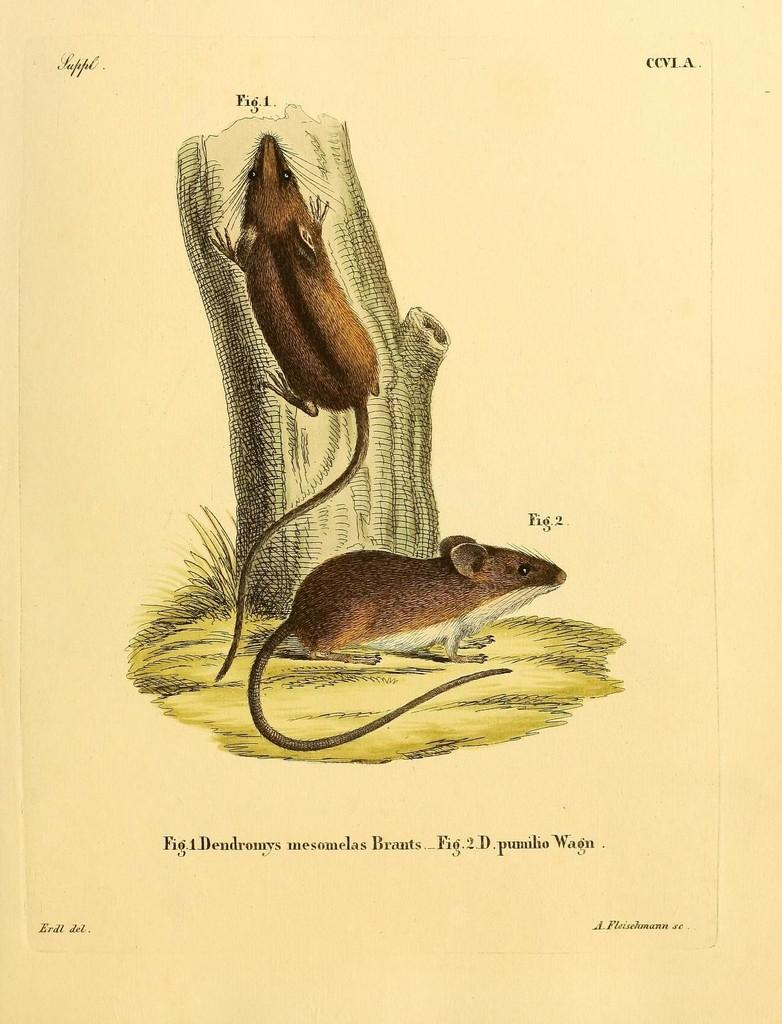What is present on the paper in the image? There is a paper in the image, and on it, there are rats, a tree trunk, and text. Can you describe the rats on the paper? The rats are depicted on the paper. What is the main subject of the image on the paper? The main subject of the image on the paper is a tree trunk. What else can be seen on the paper besides the tree trunk? There is text on the paper. What is the purpose of the cows in the image? There are no cows present in the image. How does the debt affect the rats in the image? There is no mention of debt in the image, and therefore it cannot be determined how it might affect the rats. 